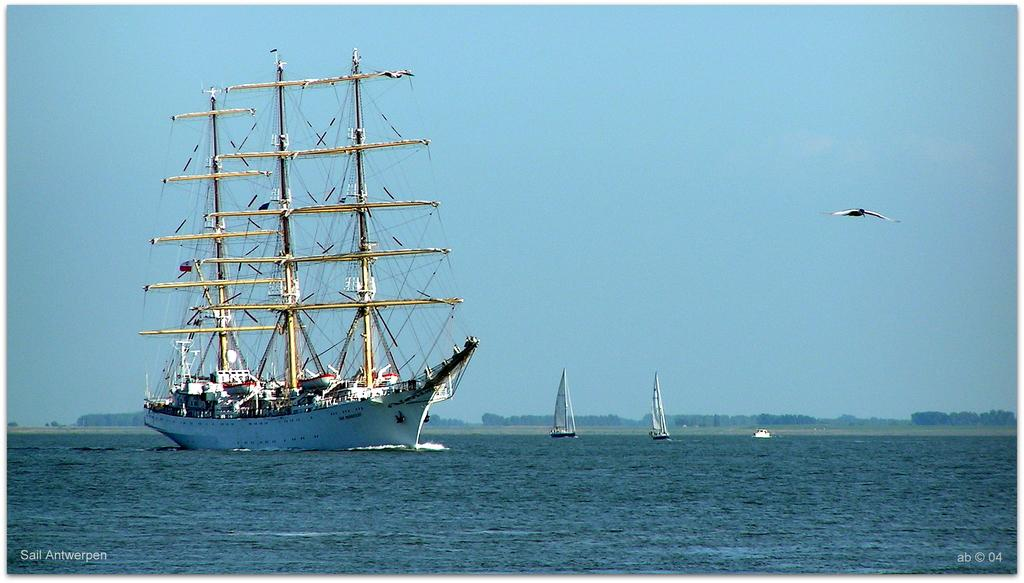What type of vehicle is in the image? There is a ship in the image. Are there any other similar vehicles in the image? Yes, there are boats in the image. What is the primary element that the ship and boats are interacting with? The ship and boats are floating on water. What can be seen in the sky in the image? There is a bird in the sky. What time of day is it in the image, based on the hour shown on the clock tower? There is no clock tower present in the image, so it is not possible to determine the time of day based on an hour. 